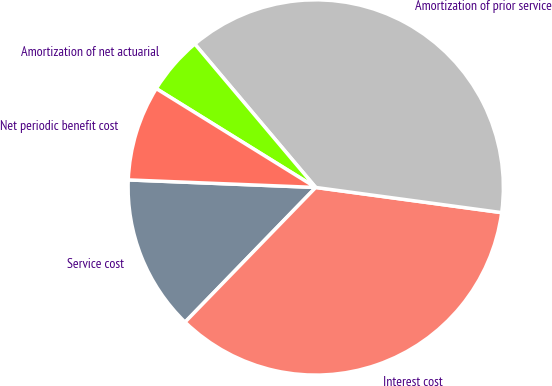Convert chart to OTSL. <chart><loc_0><loc_0><loc_500><loc_500><pie_chart><fcel>Service cost<fcel>Interest cost<fcel>Amortization of prior service<fcel>Amortization of net actuarial<fcel>Net periodic benefit cost<nl><fcel>13.38%<fcel>35.12%<fcel>38.29%<fcel>5.02%<fcel>8.19%<nl></chart> 